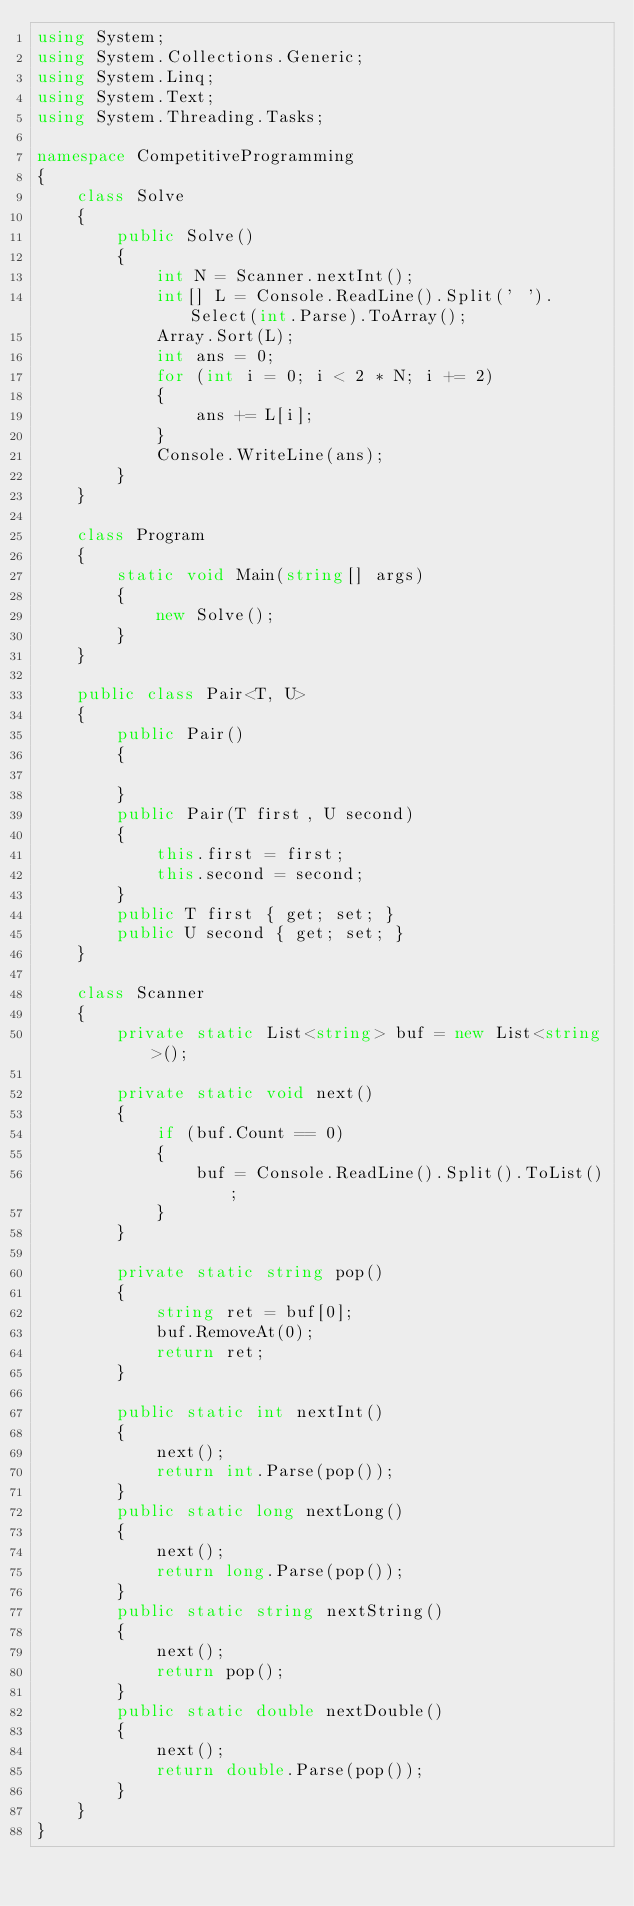Convert code to text. <code><loc_0><loc_0><loc_500><loc_500><_C#_>using System;
using System.Collections.Generic;
using System.Linq;
using System.Text;
using System.Threading.Tasks;

namespace CompetitiveProgramming
{
    class Solve
    {
        public Solve()
        {
            int N = Scanner.nextInt();
            int[] L = Console.ReadLine().Split(' ').Select(int.Parse).ToArray();
            Array.Sort(L);
            int ans = 0;
            for (int i = 0; i < 2 * N; i += 2)
            {
                ans += L[i];
            }
            Console.WriteLine(ans);
        }
    }

    class Program
    {
        static void Main(string[] args)
        {
            new Solve();
        }
    }

    public class Pair<T, U>
    {
        public Pair()
        {

        }
        public Pair(T first, U second)
        {
            this.first = first;
            this.second = second;
        }
        public T first { get; set; }
        public U second { get; set; }
    }

    class Scanner
    {
        private static List<string> buf = new List<string>();

        private static void next()
        {
            if (buf.Count == 0)
            {
                buf = Console.ReadLine().Split().ToList();
            }
        }

        private static string pop()
        {
            string ret = buf[0];
            buf.RemoveAt(0);
            return ret;
        }

        public static int nextInt()
        {
            next();
            return int.Parse(pop());
        }
        public static long nextLong()
        {
            next();
            return long.Parse(pop());
        }
        public static string nextString()
        {
            next();
            return pop();
        }
        public static double nextDouble()
        {
            next();
            return double.Parse(pop());
        }
    }
}
</code> 